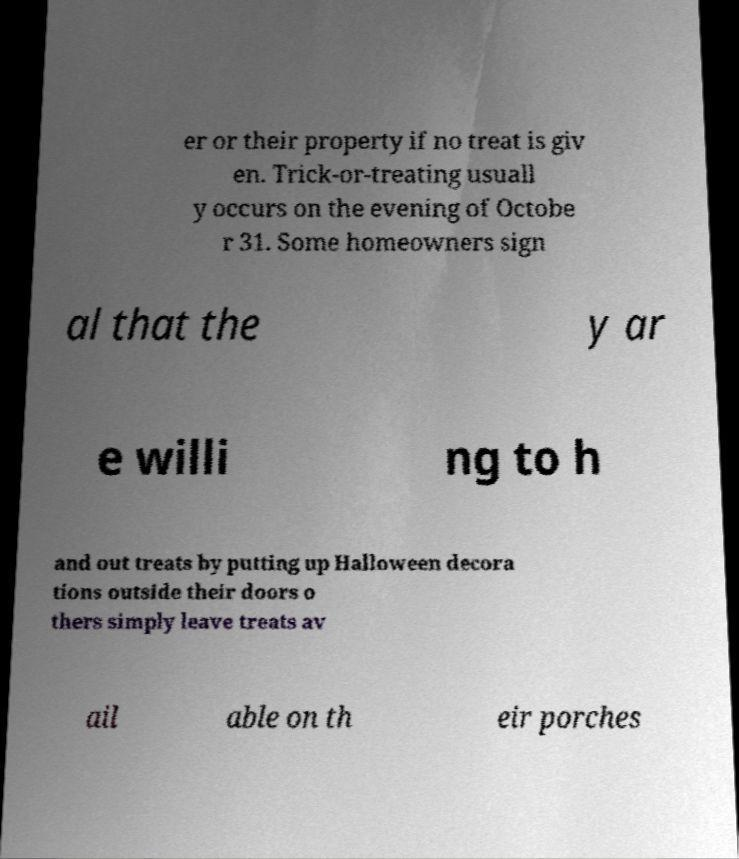Could you extract and type out the text from this image? er or their property if no treat is giv en. Trick-or-treating usuall y occurs on the evening of Octobe r 31. Some homeowners sign al that the y ar e willi ng to h and out treats by putting up Halloween decora tions outside their doors o thers simply leave treats av ail able on th eir porches 